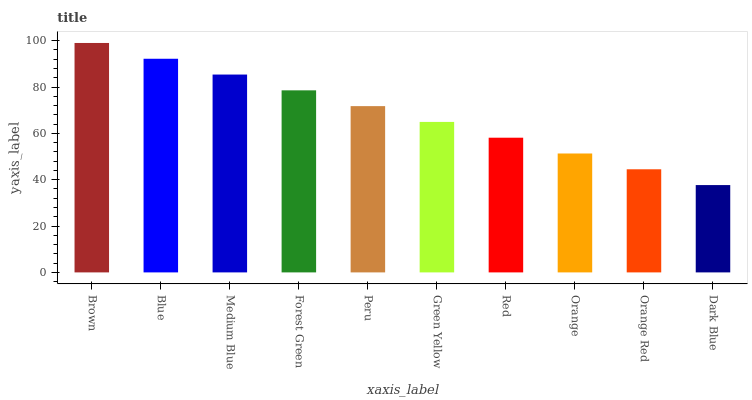Is Blue the minimum?
Answer yes or no. No. Is Blue the maximum?
Answer yes or no. No. Is Brown greater than Blue?
Answer yes or no. Yes. Is Blue less than Brown?
Answer yes or no. Yes. Is Blue greater than Brown?
Answer yes or no. No. Is Brown less than Blue?
Answer yes or no. No. Is Peru the high median?
Answer yes or no. Yes. Is Green Yellow the low median?
Answer yes or no. Yes. Is Brown the high median?
Answer yes or no. No. Is Forest Green the low median?
Answer yes or no. No. 